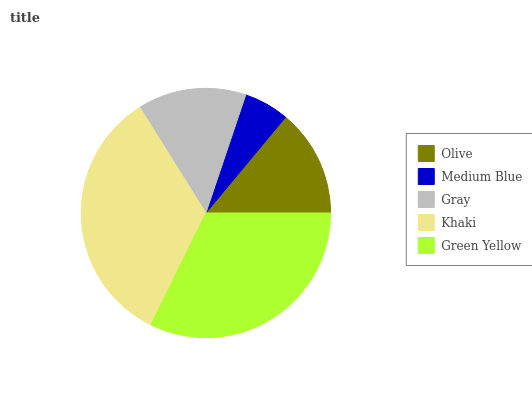Is Medium Blue the minimum?
Answer yes or no. Yes. Is Khaki the maximum?
Answer yes or no. Yes. Is Gray the minimum?
Answer yes or no. No. Is Gray the maximum?
Answer yes or no. No. Is Gray greater than Medium Blue?
Answer yes or no. Yes. Is Medium Blue less than Gray?
Answer yes or no. Yes. Is Medium Blue greater than Gray?
Answer yes or no. No. Is Gray less than Medium Blue?
Answer yes or no. No. Is Gray the high median?
Answer yes or no. Yes. Is Gray the low median?
Answer yes or no. Yes. Is Medium Blue the high median?
Answer yes or no. No. Is Olive the low median?
Answer yes or no. No. 